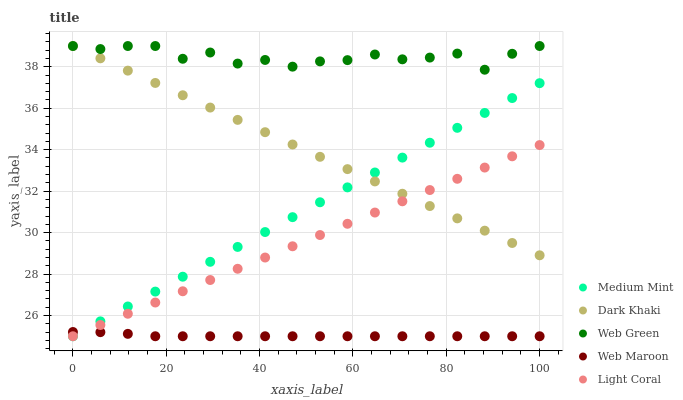Does Web Maroon have the minimum area under the curve?
Answer yes or no. Yes. Does Web Green have the maximum area under the curve?
Answer yes or no. Yes. Does Dark Khaki have the minimum area under the curve?
Answer yes or no. No. Does Dark Khaki have the maximum area under the curve?
Answer yes or no. No. Is Medium Mint the smoothest?
Answer yes or no. Yes. Is Web Green the roughest?
Answer yes or no. Yes. Is Dark Khaki the smoothest?
Answer yes or no. No. Is Dark Khaki the roughest?
Answer yes or no. No. Does Medium Mint have the lowest value?
Answer yes or no. Yes. Does Dark Khaki have the lowest value?
Answer yes or no. No. Does Web Green have the highest value?
Answer yes or no. Yes. Does Light Coral have the highest value?
Answer yes or no. No. Is Web Maroon less than Web Green?
Answer yes or no. Yes. Is Dark Khaki greater than Web Maroon?
Answer yes or no. Yes. Does Dark Khaki intersect Light Coral?
Answer yes or no. Yes. Is Dark Khaki less than Light Coral?
Answer yes or no. No. Is Dark Khaki greater than Light Coral?
Answer yes or no. No. Does Web Maroon intersect Web Green?
Answer yes or no. No. 